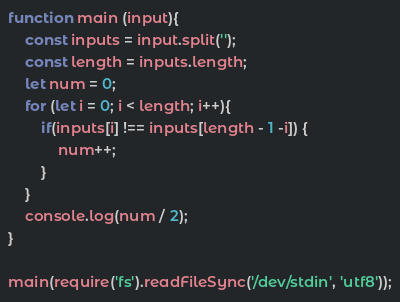<code> <loc_0><loc_0><loc_500><loc_500><_JavaScript_>function main (input){
	const inputs = input.split('');
	const length = inputs.length;
	let num = 0;
	for (let i = 0; i < length; i++){
		if(inputs[i] !== inputs[length - 1 -i]) {
			num++;
		}
	}
	console.log(num / 2);
}

main(require('fs').readFileSync('/dev/stdin', 'utf8'));</code> 